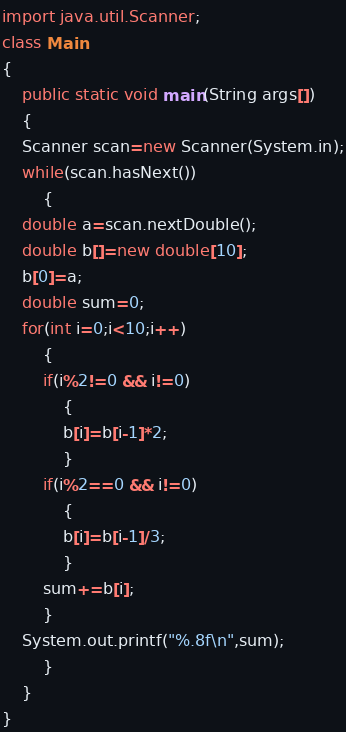<code> <loc_0><loc_0><loc_500><loc_500><_Java_>import java.util.Scanner;
class Main
{
    public static void main(String args[])
    {
	Scanner scan=new Scanner(System.in);
	while(scan.hasNext())
	    {
	double a=scan.nextDouble();
	double b[]=new double[10];
	b[0]=a;
	double sum=0;
	for(int i=0;i<10;i++)
	    {
		if(i%2!=0 && i!=0)
		    {
			b[i]=b[i-1]*2;
		    }
		if(i%2==0 && i!=0)
		    {
			b[i]=b[i-1]/3;
		    }
		sum+=b[i];
	    }
	System.out.printf("%.8f\n",sum);
	    }
    }
}</code> 